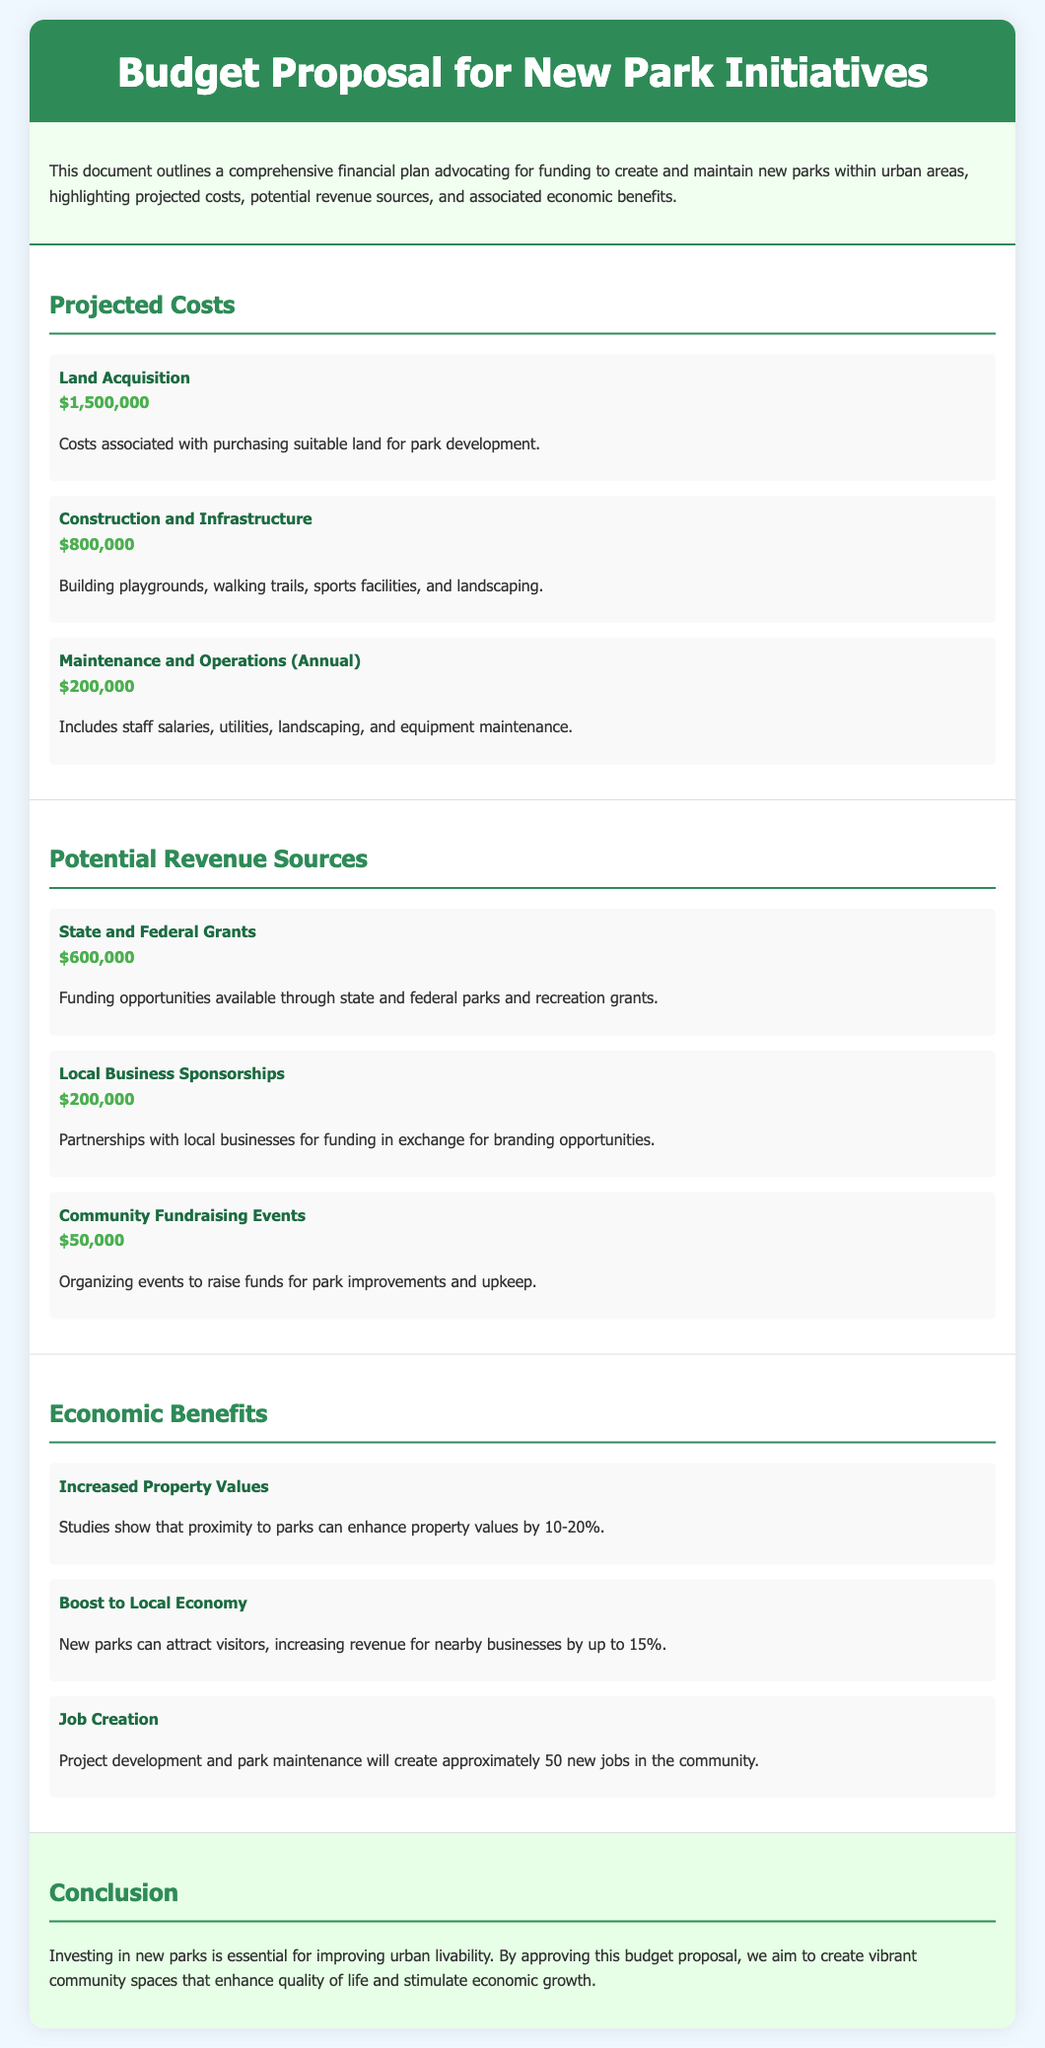What is the total projected cost? The total projected cost is the sum of Land Acquisition, Construction and Infrastructure, and Annual Maintenance costs, which is $1,500,000 + $800,000 + $200,000 = $2,500,000.
Answer: $2,500,000 How much funding is requested from local business sponsorships? Local Business Sponsorships are expected to generate $200,000 as outlined in the Potential Revenue Sources section of the document.
Answer: $200,000 What annual maintenance cost is outlined in the proposal? The Maintenance and Operations cost is specified to be $200,000 annually in the Projected Costs section.
Answer: $200,000 What is one economic benefit mentioned? Increased Property Values is mentioned as an economic benefit, indicating proximity to parks can enhance values by 10-20%.
Answer: Increased Property Values How many new jobs will the park initiative create? The document states that approximately 50 new jobs will be created through project development and maintenance.
Answer: 50 What is the total amount of funding expected from state and federal grants? The expected funding from State and Federal Grants is quantified as $600,000 in the Potential Revenue Sources section.
Answer: $600,000 What type of events can raise funds for park improvements? Community Fundraising Events are cited as a source to raise funds, estimated at $50,000 according to revenue sources.
Answer: Community Fundraising Events What is the total amount allocated for Construction and Infrastructure? The total for Construction and Infrastructure is specifically stated to be $800,000 in the Projected Costs section of the document.
Answer: $800,000 